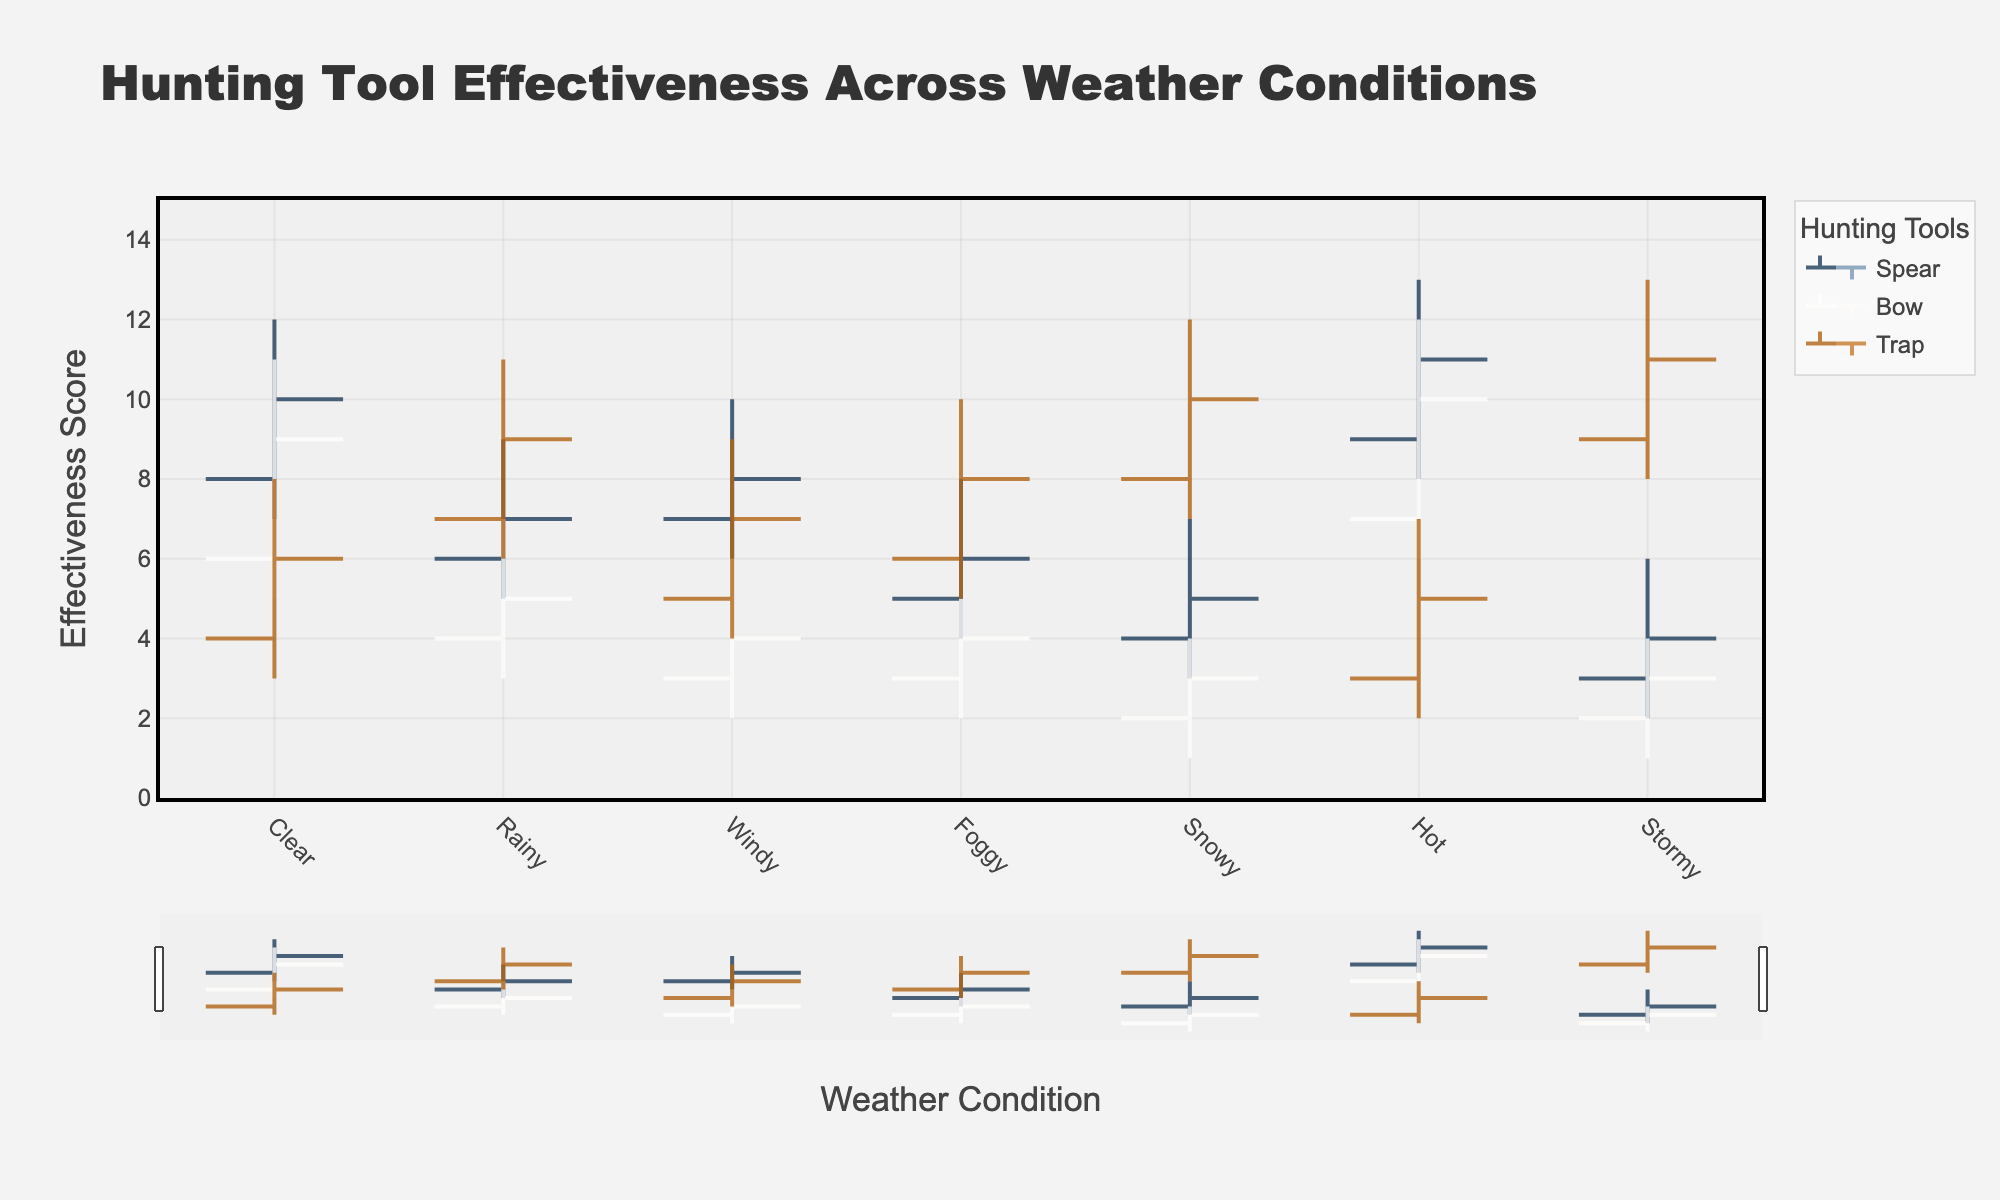what is the weather condition with the highest effectiveness score for the spear? Under 'Hot' weather condition, the Spear shows its highest effectiveness with a high score of 13.
Answer: Hot how does the effectiveness of the bow compare between 'Clear' and 'Rainy' weather conditions? The Bow has a close difference with scores of (6, 11) under 'Clear,' closing at 9; while in 'Rainy,' the scores are (4, 7) close at 5. Thus, the Bow is more effective in 'Clear' weather than 'Rainy'.
Answer: Clear which hunting tool has the lowest effectiveness score under 'Stormy' weather? Under 'Stormy,' the Bow has the lowest effectiveness, with low, open, close, and high scores being (1, 2, 3, 4).
Answer: Bow What is the average high effectiveness score of the spear across all weather conditions? Summing up high scores for Spear: 12+9+10+8+7+13+6 = 65. There are 7 weather conditions, so 65/7 = approximately 9.29.
Answer: 9.29 Under what weather condition does the trap show the biggest difference between its high and low effectiveness scores? The biggest difference for the Trap happens under 'Stormy' (13-8=5), which is the largest spread compared to other weather conditions.
Answer: Stormy what is the range of the effectiveness score for the bow under 'Foggy' weather condition? Under 'Foggy,' the Bow's effectiveness ranges from 2 to 5. Thus, its range is 5 - 2 = 3.
Answer: 3 which hunting tool has the highest average closing effectiveness score across all weather conditions? To find the tool: Add up closing scores for each tool then average:
   - Spear: (10+7+8+6+5+11+4)/7 = 7.29
   - Bow: (9+5+4+4+3+10+3)/7 = 5.43 
   - Trap: (6+9+7+8+10+5+11)/7 = 8 
   Trap has the highest average closing score.
Answer: Trap 